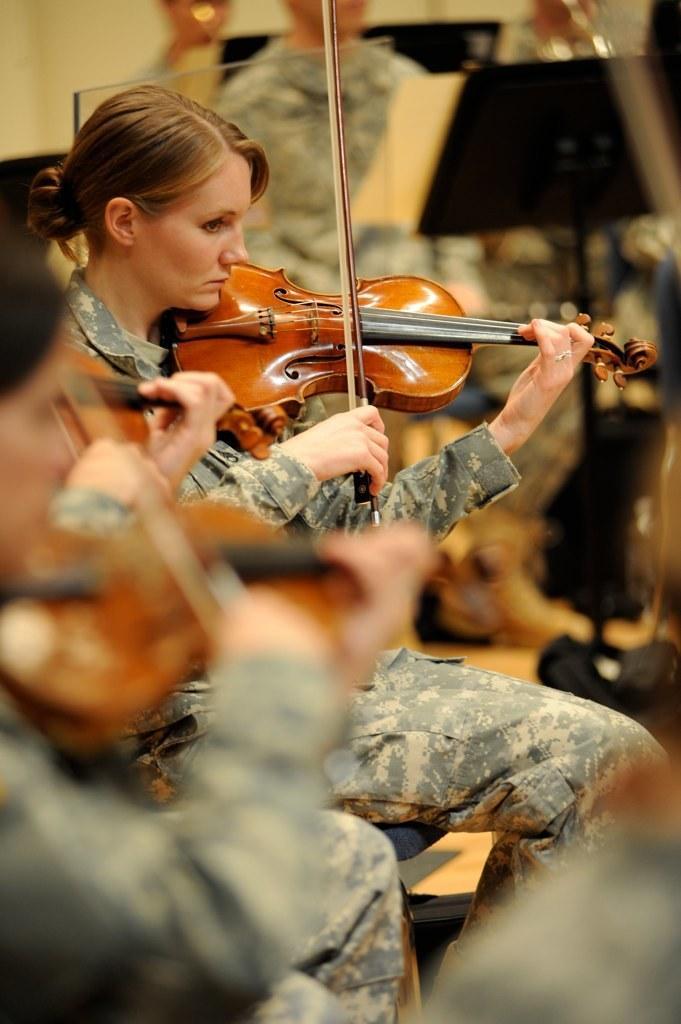How would you summarize this image in a sentence or two? In this picture there is a woman sitting on a chair,she is playing a violin. She is wearing a shirt and a trouser. To the left bottom there is another woman playing a violin and she is blurred. 